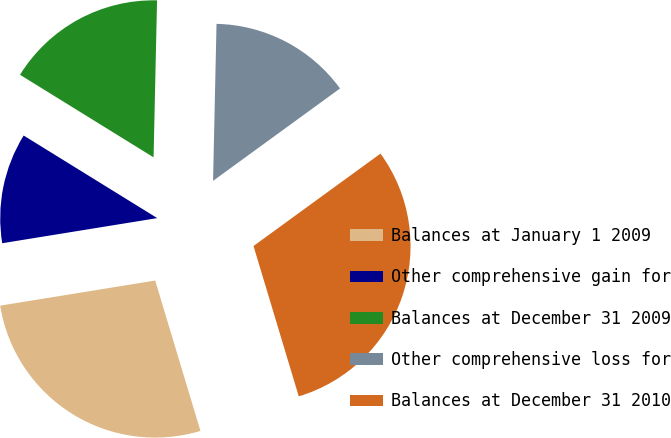Convert chart. <chart><loc_0><loc_0><loc_500><loc_500><pie_chart><fcel>Balances at January 1 2009<fcel>Other comprehensive gain for<fcel>Balances at December 31 2009<fcel>Other comprehensive loss for<fcel>Balances at December 31 2010<nl><fcel>27.1%<fcel>11.37%<fcel>16.54%<fcel>14.64%<fcel>30.36%<nl></chart> 